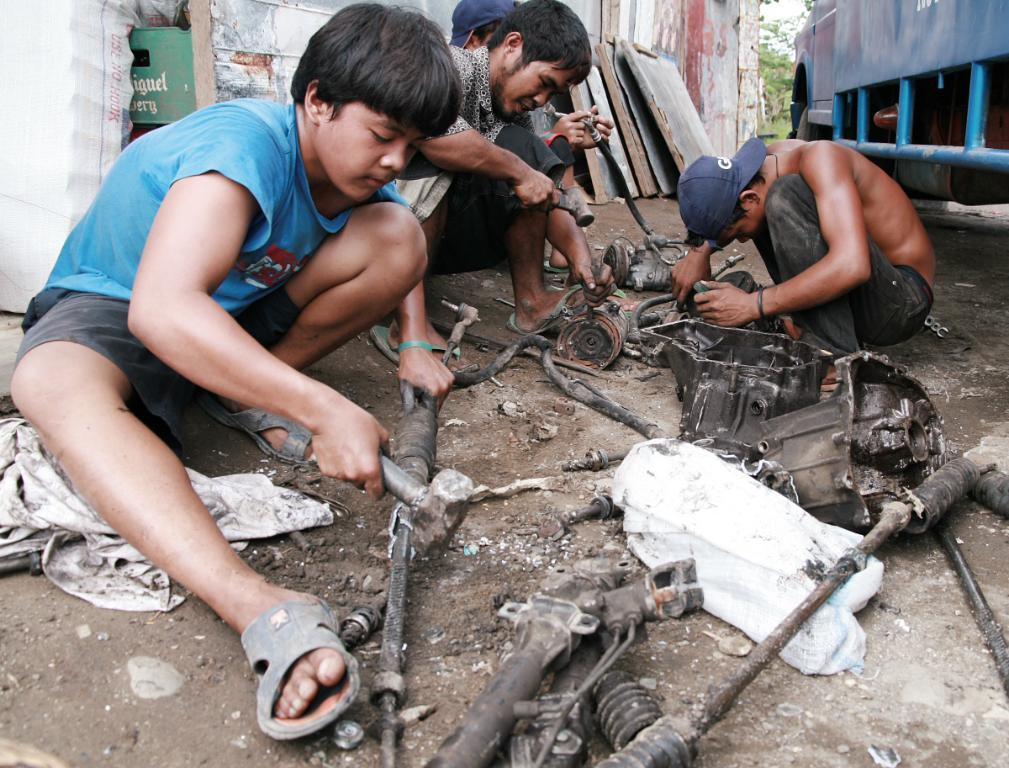How many people are in the image? There are four persons in the image. What are the persons doing in the image? The persons are sitting and repairing something. What can be seen in the background of the image? There is a vehicle, trees, and other objects in the background of the image. What type of question is being asked in the image? There is no question being asked in the image; it shows four persons sitting and repairing something. 